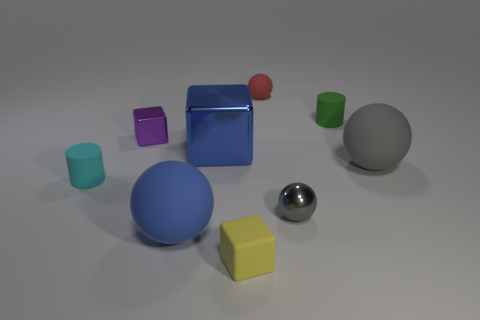What is the size of the blue object that is the same shape as the small yellow rubber object?
Provide a succinct answer. Large. What color is the other large metal thing that is the same shape as the yellow object?
Offer a very short reply. Blue. What number of other yellow things are the same size as the yellow thing?
Make the answer very short. 0. There is a small gray ball; how many tiny rubber cylinders are left of it?
Make the answer very short. 1. What material is the sphere behind the tiny metallic thing that is to the left of the small yellow matte object made of?
Ensure brevity in your answer.  Rubber. Are there any other large shiny blocks that have the same color as the big block?
Keep it short and to the point. No. What is the size of the red ball that is the same material as the cyan cylinder?
Ensure brevity in your answer.  Small. Is there any other thing of the same color as the tiny matte cube?
Provide a short and direct response. No. The tiny sphere that is behind the large block is what color?
Keep it short and to the point. Red. There is a small ball that is behind the small sphere that is in front of the tiny red rubber object; are there any tiny rubber blocks that are behind it?
Your answer should be very brief. No. 